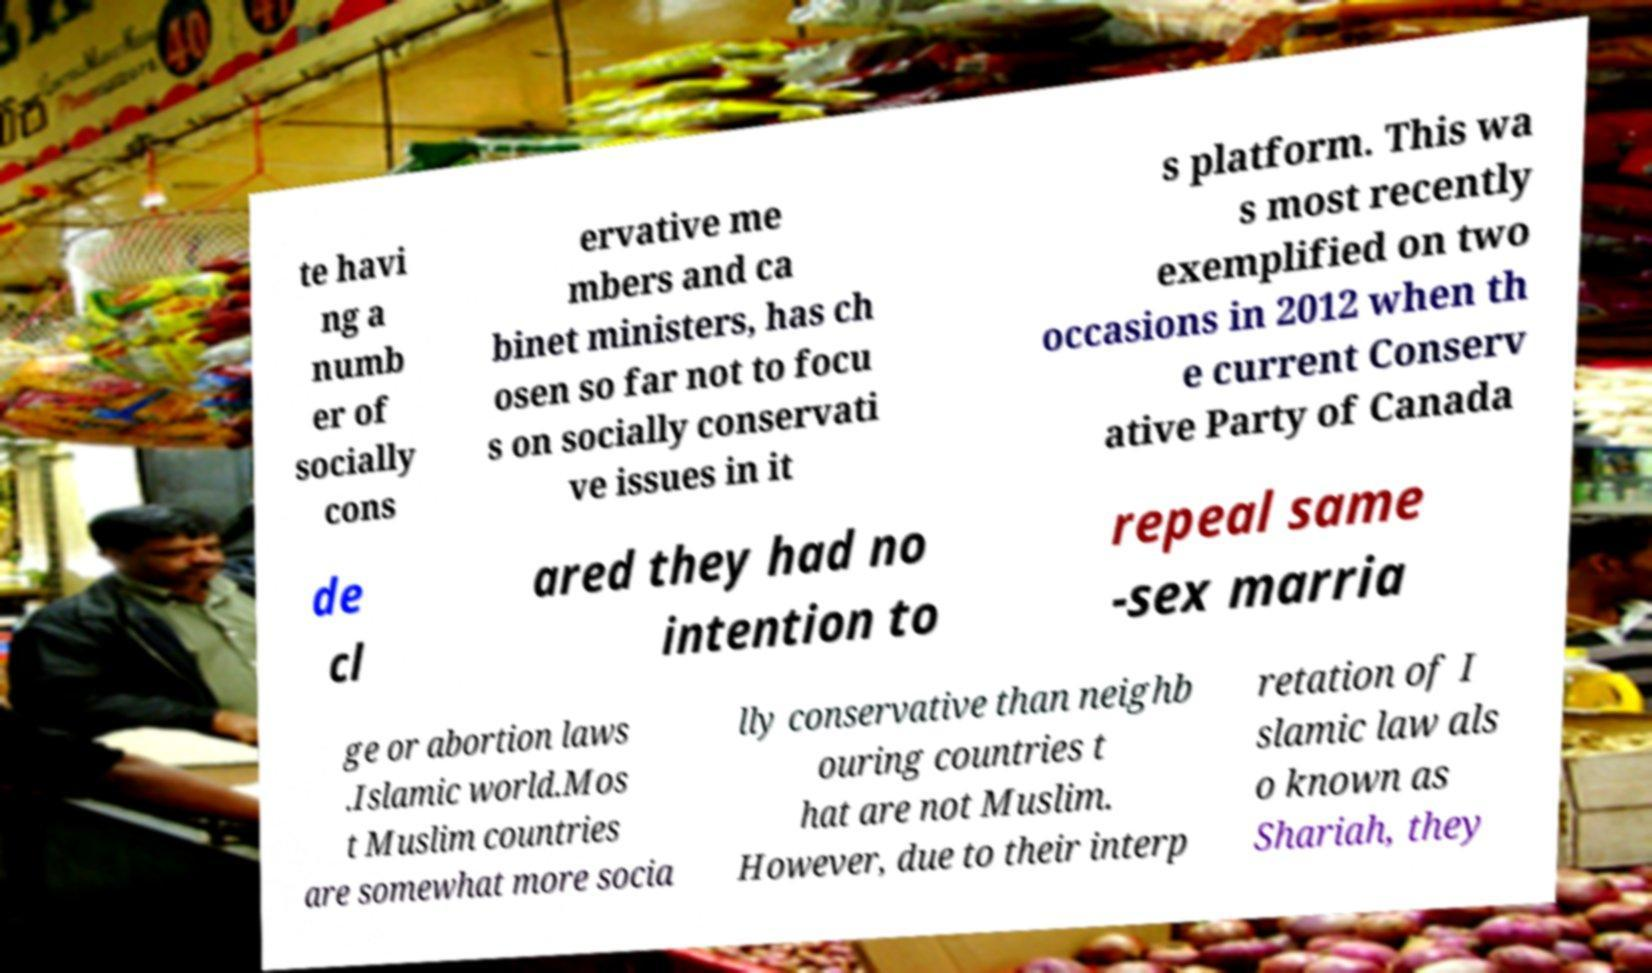Can you accurately transcribe the text from the provided image for me? te havi ng a numb er of socially cons ervative me mbers and ca binet ministers, has ch osen so far not to focu s on socially conservati ve issues in it s platform. This wa s most recently exemplified on two occasions in 2012 when th e current Conserv ative Party of Canada de cl ared they had no intention to repeal same -sex marria ge or abortion laws .Islamic world.Mos t Muslim countries are somewhat more socia lly conservative than neighb ouring countries t hat are not Muslim. However, due to their interp retation of I slamic law als o known as Shariah, they 